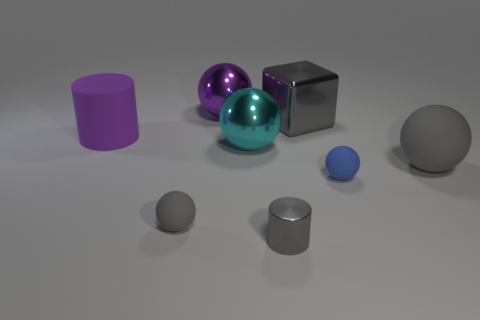Is there any other thing that is the same shape as the large gray metal object? No, there isn't any other object identical in shape to the large gray metal cube in the image. However, there is a smaller, similarly shaped metal object which is a cube as well, but it's not the same size. 